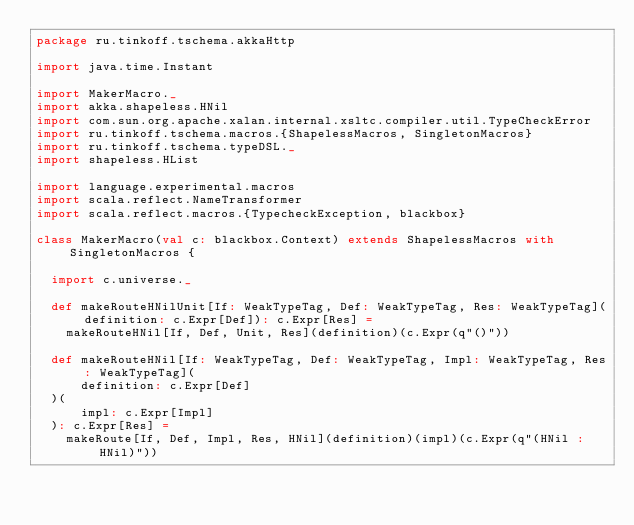<code> <loc_0><loc_0><loc_500><loc_500><_Scala_>package ru.tinkoff.tschema.akkaHttp

import java.time.Instant

import MakerMacro._
import akka.shapeless.HNil
import com.sun.org.apache.xalan.internal.xsltc.compiler.util.TypeCheckError
import ru.tinkoff.tschema.macros.{ShapelessMacros, SingletonMacros}
import ru.tinkoff.tschema.typeDSL._
import shapeless.HList

import language.experimental.macros
import scala.reflect.NameTransformer
import scala.reflect.macros.{TypecheckException, blackbox}

class MakerMacro(val c: blackbox.Context) extends ShapelessMacros with SingletonMacros {

  import c.universe._

  def makeRouteHNilUnit[If: WeakTypeTag, Def: WeakTypeTag, Res: WeakTypeTag](definition: c.Expr[Def]): c.Expr[Res] =
    makeRouteHNil[If, Def, Unit, Res](definition)(c.Expr(q"()"))

  def makeRouteHNil[If: WeakTypeTag, Def: WeakTypeTag, Impl: WeakTypeTag, Res: WeakTypeTag](
      definition: c.Expr[Def]
  )(
      impl: c.Expr[Impl]
  ): c.Expr[Res] =
    makeRoute[If, Def, Impl, Res, HNil](definition)(impl)(c.Expr(q"(HNil : HNil)"))
</code> 